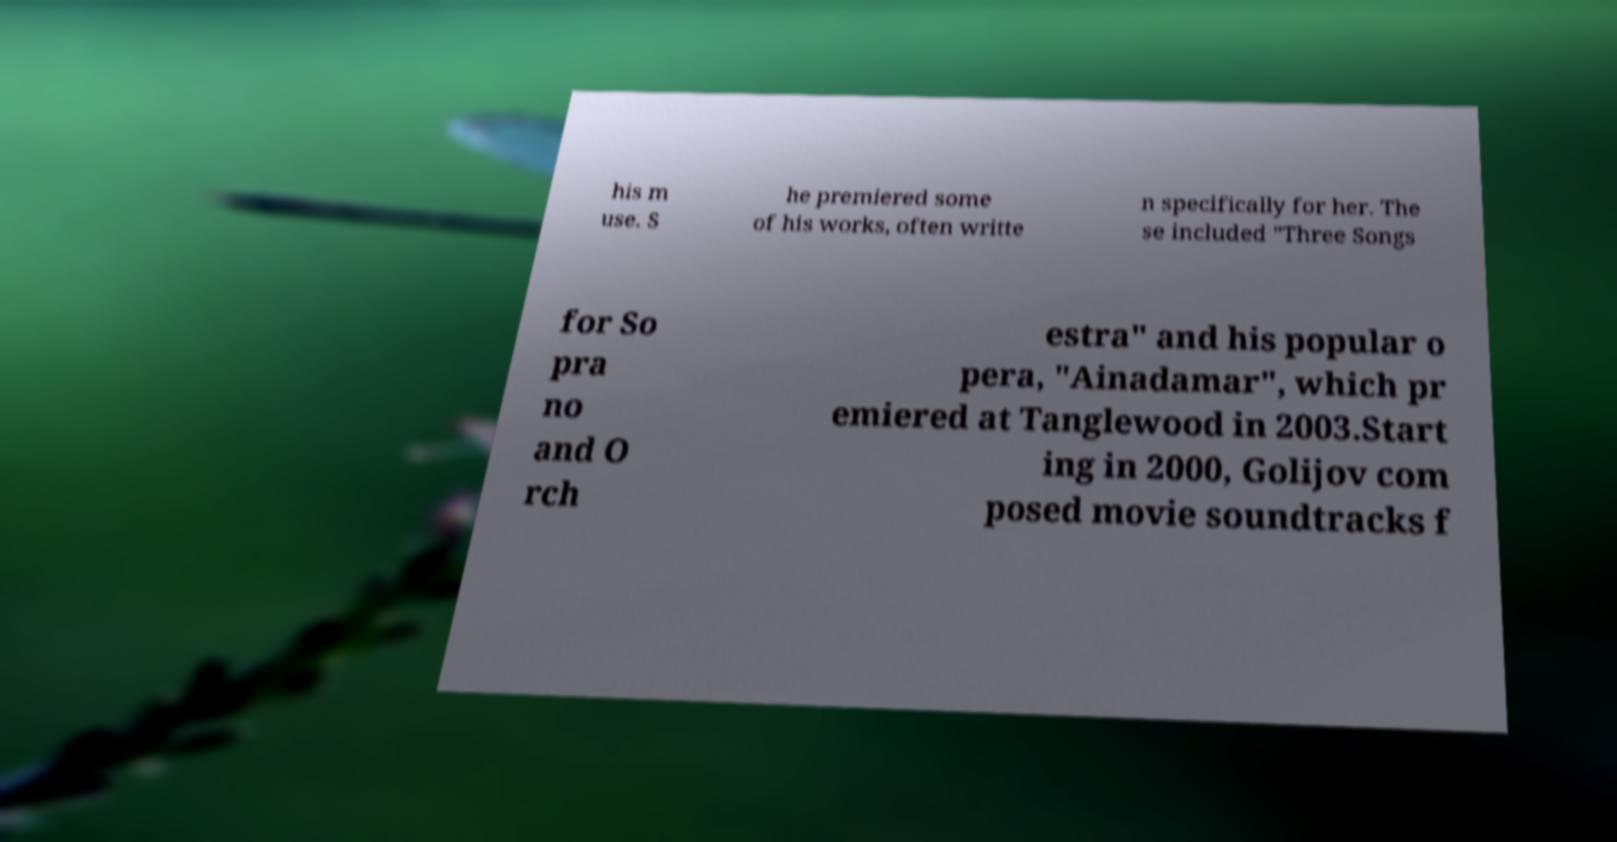There's text embedded in this image that I need extracted. Can you transcribe it verbatim? his m use. S he premiered some of his works, often writte n specifically for her. The se included "Three Songs for So pra no and O rch estra" and his popular o pera, "Ainadamar", which pr emiered at Tanglewood in 2003.Start ing in 2000, Golijov com posed movie soundtracks f 